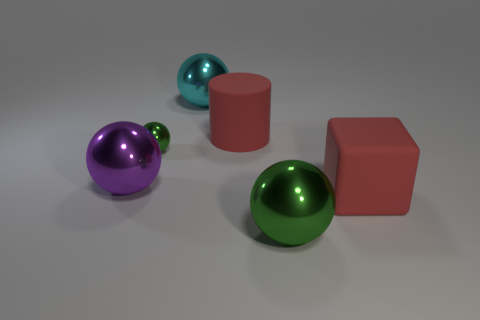What number of large green spheres are behind the green shiny sphere behind the green thing in front of the tiny green ball?
Ensure brevity in your answer.  0. There is a big metallic object that is behind the big green metal object and on the right side of the purple thing; what shape is it?
Ensure brevity in your answer.  Sphere. Are there fewer big balls in front of the purple thing than large red blocks?
Offer a very short reply. No. What number of small things are either green shiny balls or red matte cylinders?
Your answer should be very brief. 1. How big is the purple shiny sphere?
Your response must be concise. Large. Is there anything else that has the same material as the large green sphere?
Provide a short and direct response. Yes. How many small green balls are to the left of the purple object?
Give a very brief answer. 0. What size is the cyan metallic object that is the same shape as the purple object?
Your answer should be compact. Large. There is a metallic sphere that is in front of the tiny metal sphere and to the right of the large purple metal thing; what is its size?
Offer a very short reply. Large. Is the color of the large rubber cylinder the same as the metallic thing that is right of the large red cylinder?
Your answer should be compact. No. 